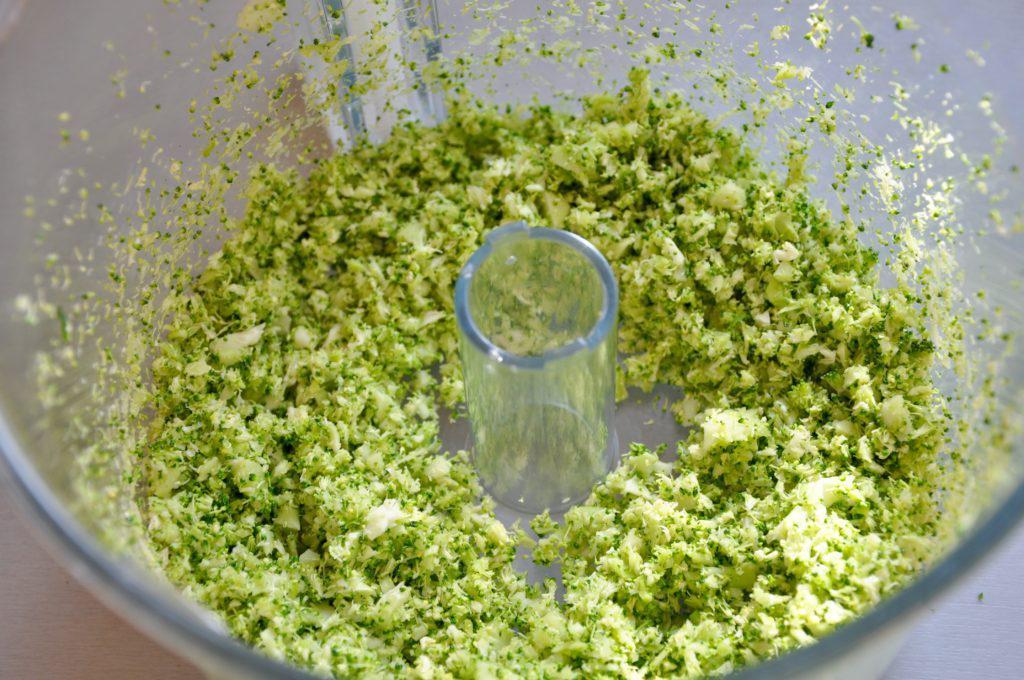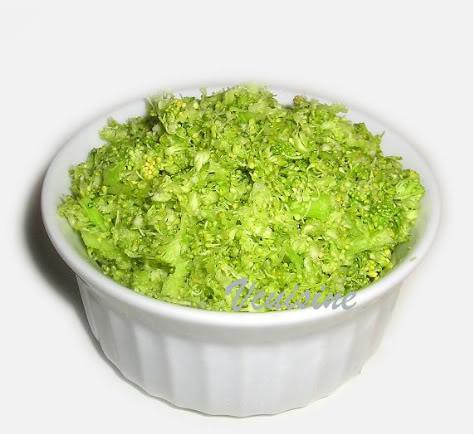The first image is the image on the left, the second image is the image on the right. Assess this claim about the two images: "One image features whole broccoli pieces in a bowl.". Correct or not? Answer yes or no. No. 